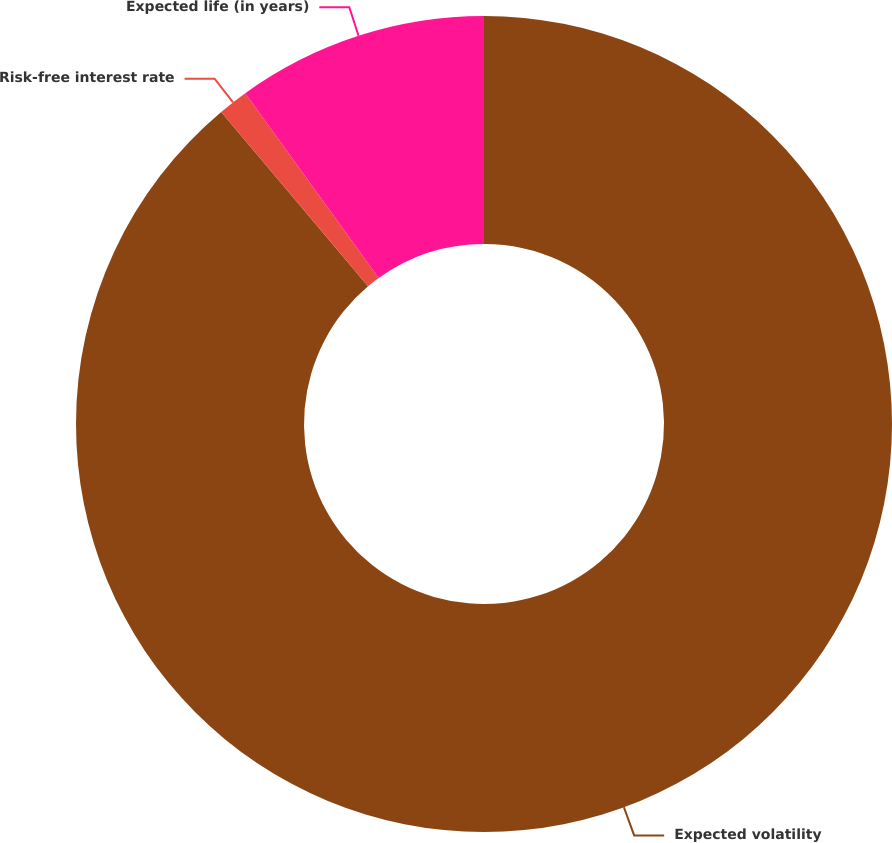Convert chart. <chart><loc_0><loc_0><loc_500><loc_500><pie_chart><fcel>Expected volatility<fcel>Risk-free interest rate<fcel>Expected life (in years)<nl><fcel>88.86%<fcel>1.19%<fcel>9.95%<nl></chart> 